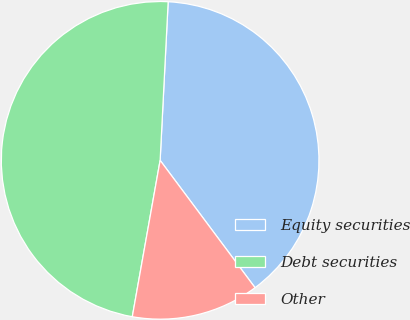Convert chart to OTSL. <chart><loc_0><loc_0><loc_500><loc_500><pie_chart><fcel>Equity securities<fcel>Debt securities<fcel>Other<nl><fcel>39.0%<fcel>48.0%<fcel>13.0%<nl></chart> 